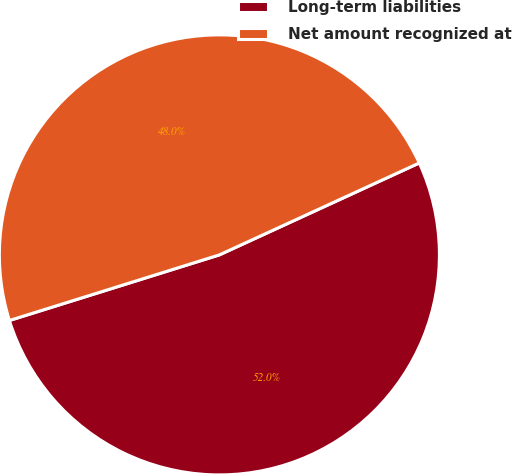Convert chart to OTSL. <chart><loc_0><loc_0><loc_500><loc_500><pie_chart><fcel>Long-term liabilities<fcel>Net amount recognized at<nl><fcel>52.04%<fcel>47.96%<nl></chart> 